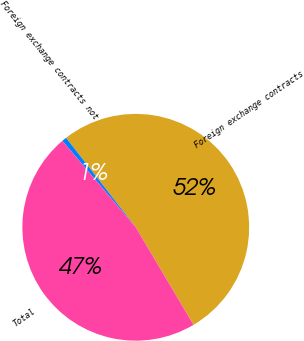Convert chart. <chart><loc_0><loc_0><loc_500><loc_500><pie_chart><fcel>Foreign exchange contracts<fcel>Foreign exchange contracts not<fcel>Total<nl><fcel>52.03%<fcel>0.68%<fcel>47.3%<nl></chart> 